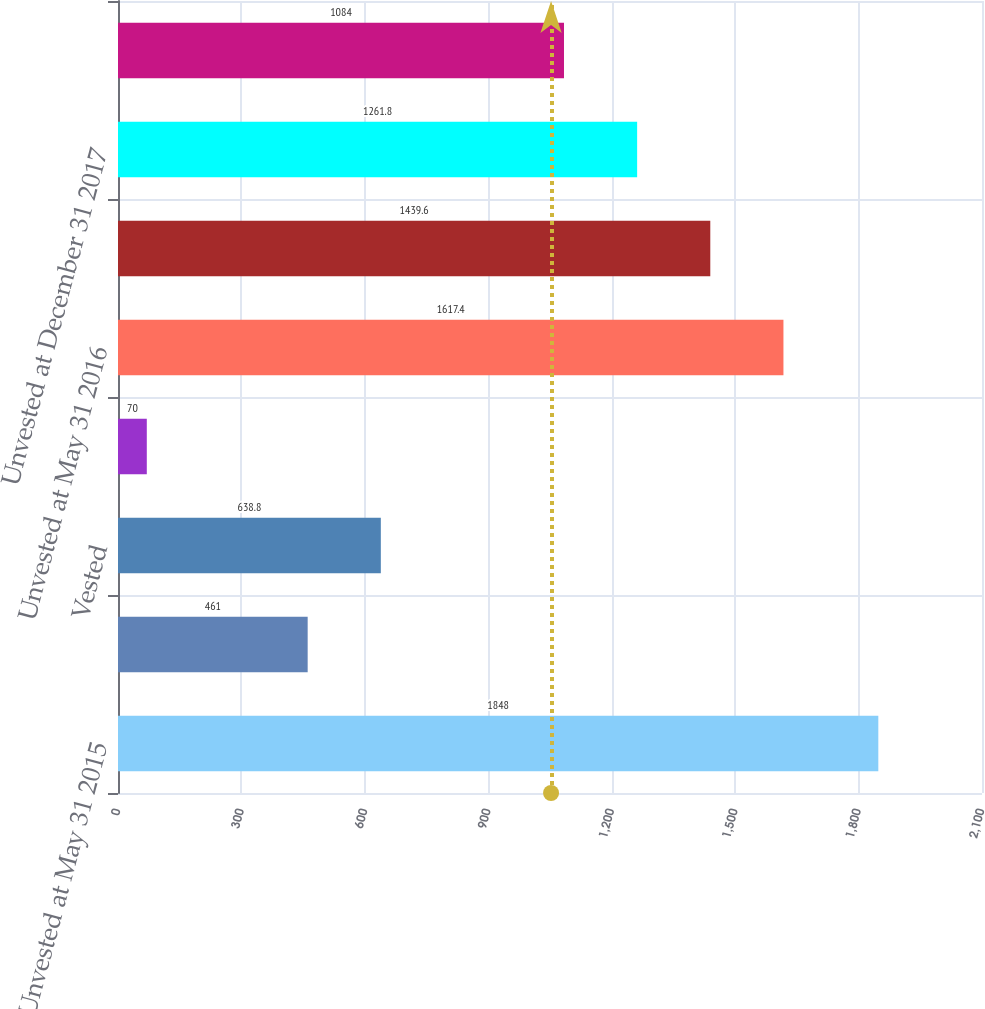<chart> <loc_0><loc_0><loc_500><loc_500><bar_chart><fcel>Unvested at May 31 2015<fcel>Granted<fcel>Vested<fcel>Forfeited<fcel>Unvested at May 31 2016<fcel>Unvested at December 31 2016<fcel>Unvested at December 31 2017<fcel>Unvested at December 31 2018<nl><fcel>1848<fcel>461<fcel>638.8<fcel>70<fcel>1617.4<fcel>1439.6<fcel>1261.8<fcel>1084<nl></chart> 